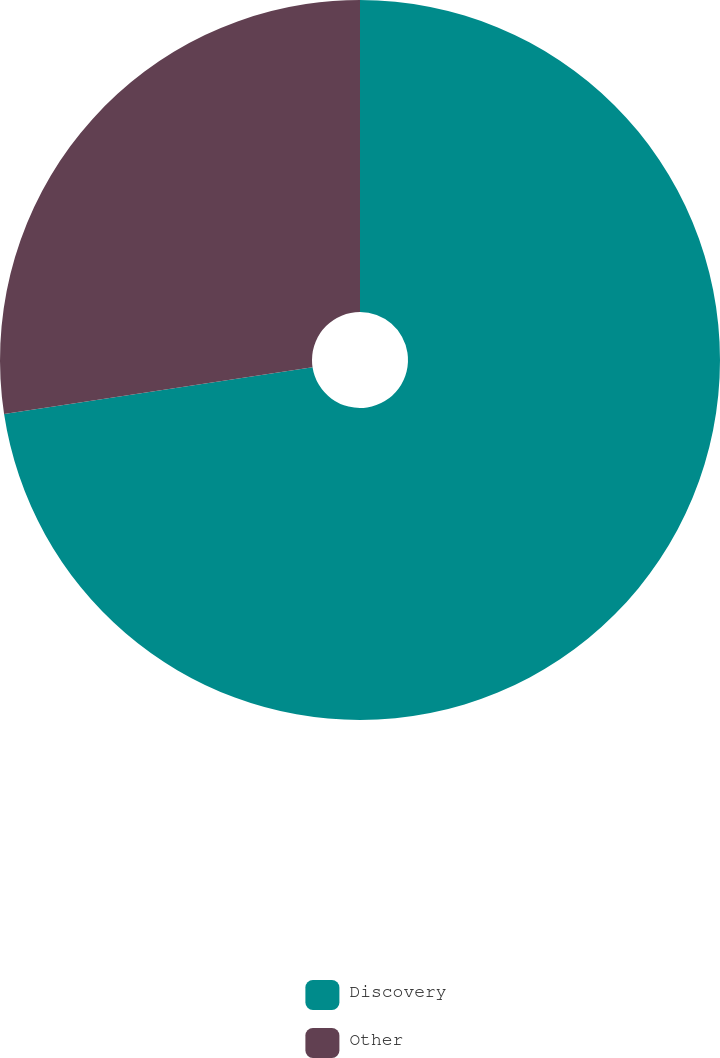<chart> <loc_0><loc_0><loc_500><loc_500><pie_chart><fcel>Discovery<fcel>Other<nl><fcel>72.6%<fcel>27.4%<nl></chart> 